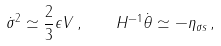<formula> <loc_0><loc_0><loc_500><loc_500>\dot { \sigma } ^ { 2 } \simeq \frac { 2 } { 3 } \epsilon V \, , \quad H ^ { - 1 } \dot { \theta } \simeq - \eta _ { \sigma s } \, ,</formula> 